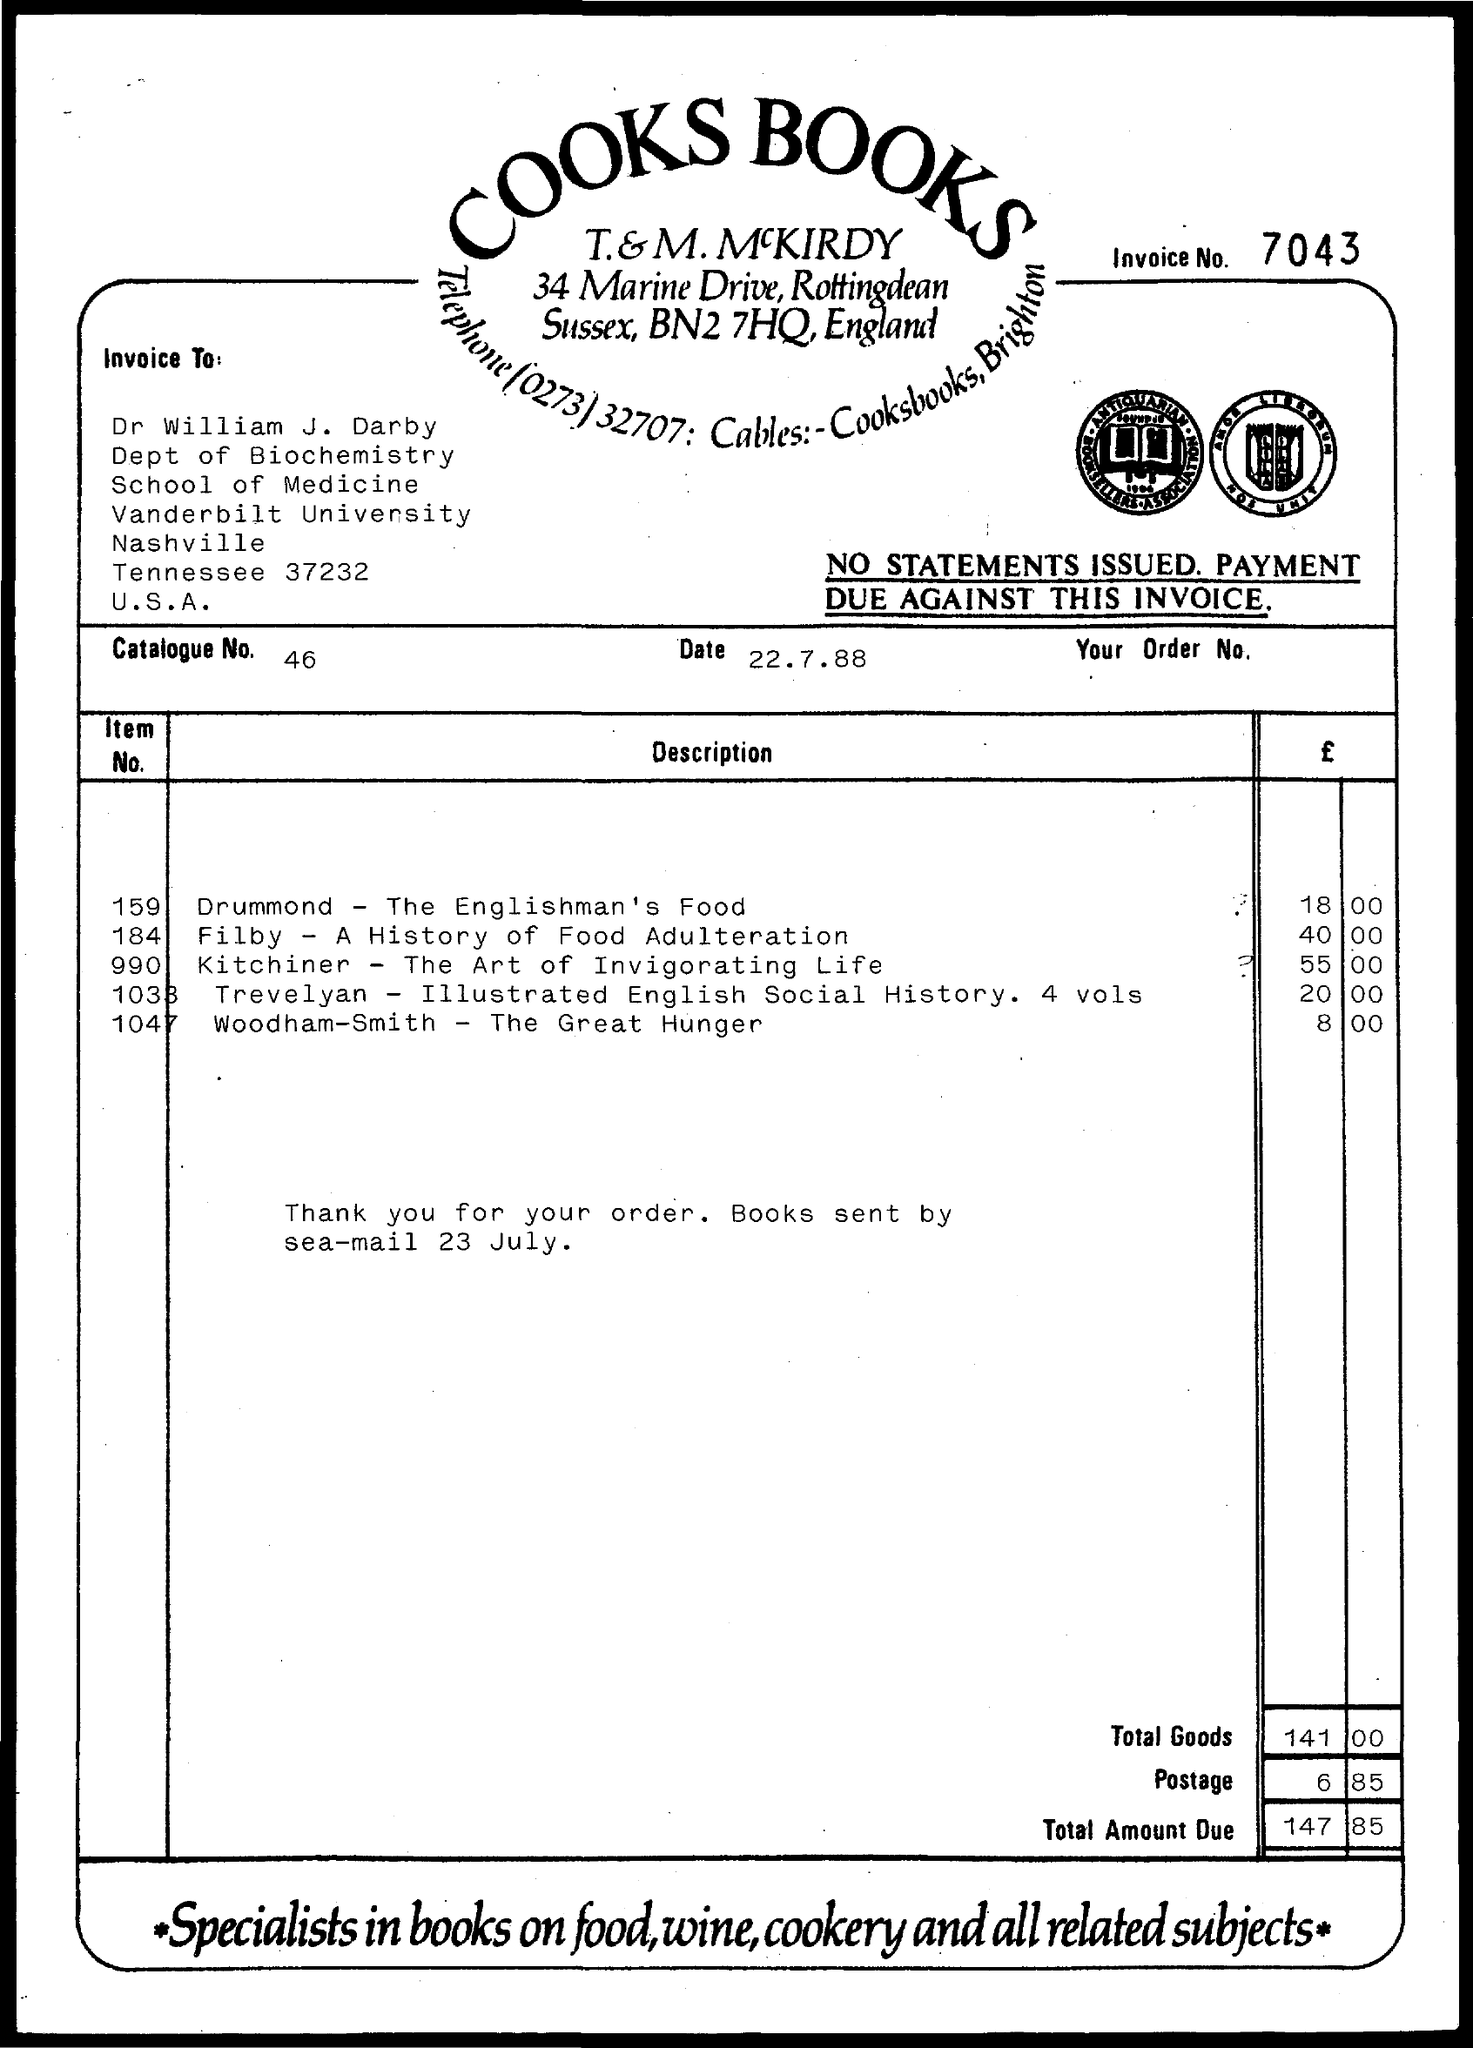Indicate a few pertinent items in this graphic. The date is July 22, 1988. Item No. 159 has a price of 18.00. The price for Item No. 990 is 55.00. What is the invoice number? 7043..." is a question that requires an answer to determine the specific invoice number being referred to. The catalog number is 46... 